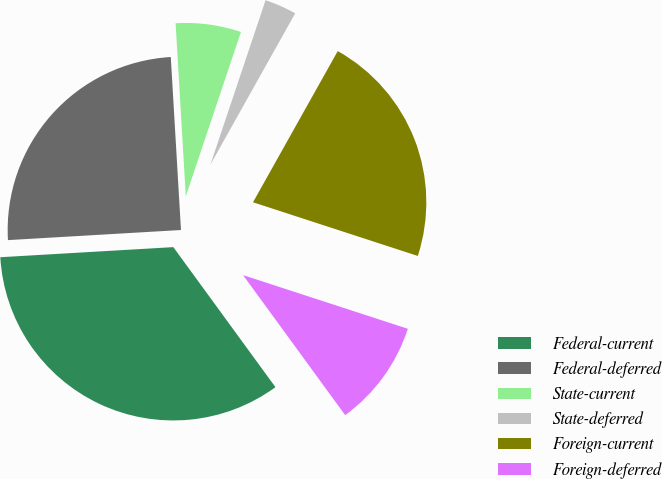Convert chart to OTSL. <chart><loc_0><loc_0><loc_500><loc_500><pie_chart><fcel>Federal-current<fcel>Federal-deferred<fcel>State-current<fcel>State-deferred<fcel>Foreign-current<fcel>Foreign-deferred<nl><fcel>34.1%<fcel>24.99%<fcel>6.09%<fcel>2.98%<fcel>21.88%<fcel>9.96%<nl></chart> 